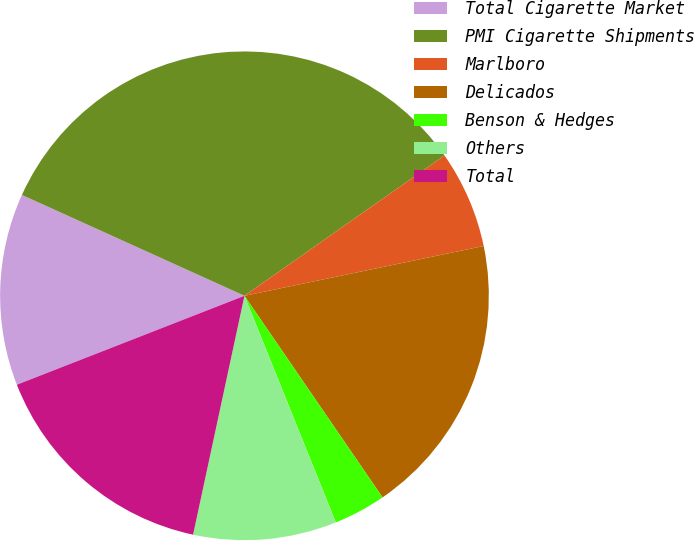Convert chart. <chart><loc_0><loc_0><loc_500><loc_500><pie_chart><fcel>Total Cigarette Market<fcel>PMI Cigarette Shipments<fcel>Marlboro<fcel>Delicados<fcel>Benson & Hedges<fcel>Others<fcel>Total<nl><fcel>12.7%<fcel>33.49%<fcel>6.47%<fcel>18.71%<fcel>3.46%<fcel>9.47%<fcel>15.7%<nl></chart> 